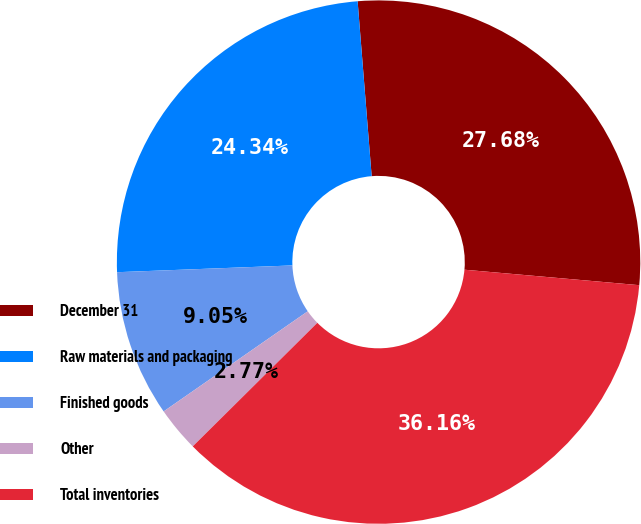<chart> <loc_0><loc_0><loc_500><loc_500><pie_chart><fcel>December 31<fcel>Raw materials and packaging<fcel>Finished goods<fcel>Other<fcel>Total inventories<nl><fcel>27.68%<fcel>24.34%<fcel>9.05%<fcel>2.77%<fcel>36.16%<nl></chart> 